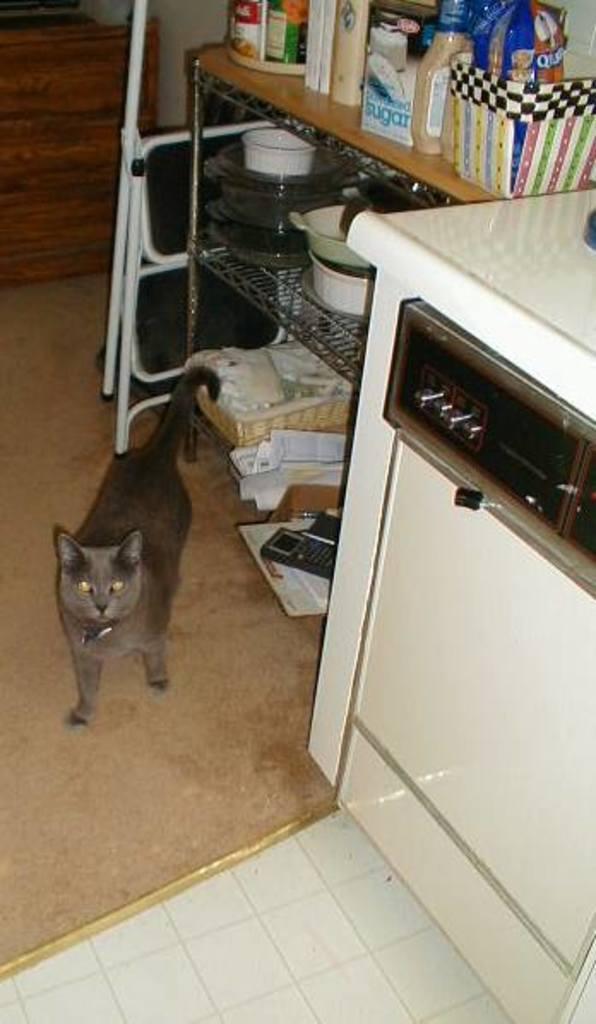Can you describe this image briefly? In this image, we can see a cat on the floor and in the background, there are stands and we can see a rack with baskets, vessels, containers and there are some packets and some other objects and there is a wall. 